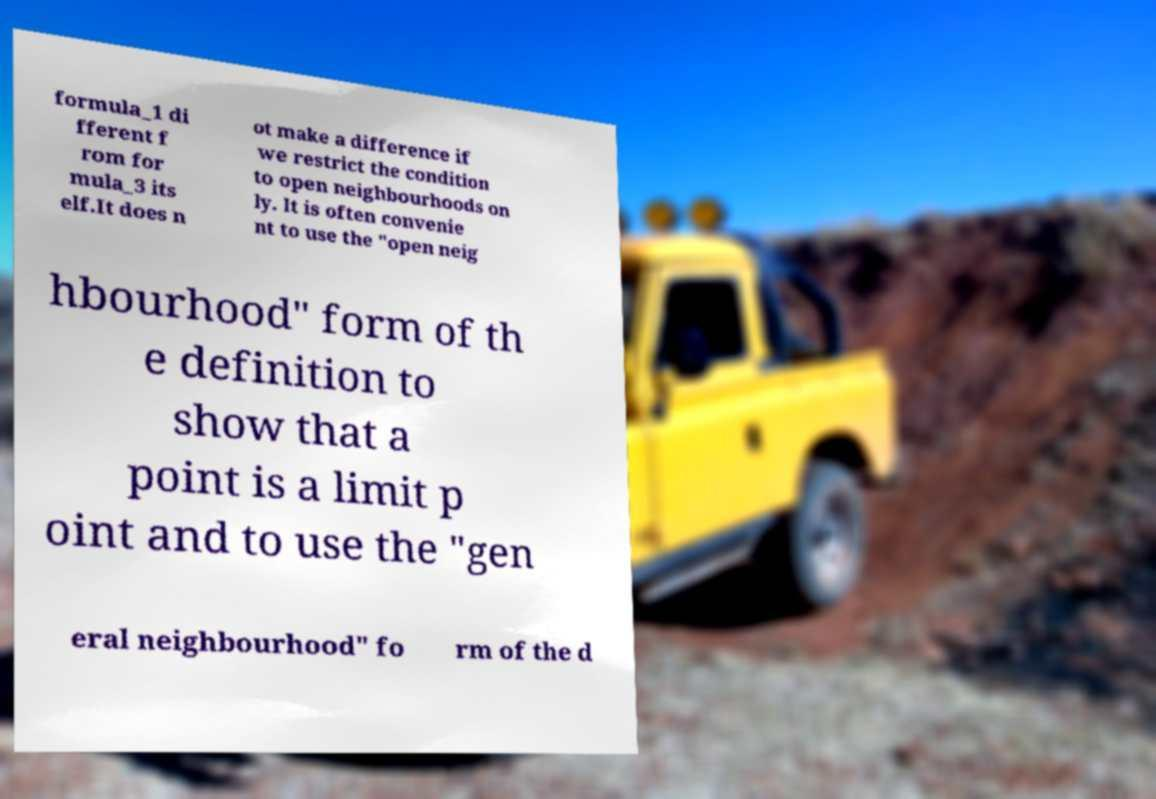There's text embedded in this image that I need extracted. Can you transcribe it verbatim? formula_1 di fferent f rom for mula_3 its elf.It does n ot make a difference if we restrict the condition to open neighbourhoods on ly. It is often convenie nt to use the "open neig hbourhood" form of th e definition to show that a point is a limit p oint and to use the "gen eral neighbourhood" fo rm of the d 